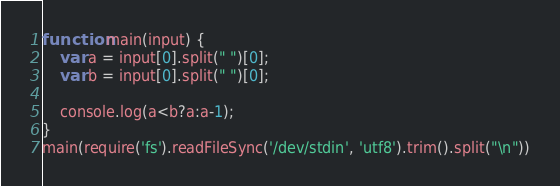<code> <loc_0><loc_0><loc_500><loc_500><_JavaScript_>function main(input) {
    var a = input[0].split(" ")[0];
    var b = input[0].split(" ")[0];
    
    console.log(a<b?a:a-1);
}
main(require('fs').readFileSync('/dev/stdin', 'utf8').trim().split("\n"))
</code> 